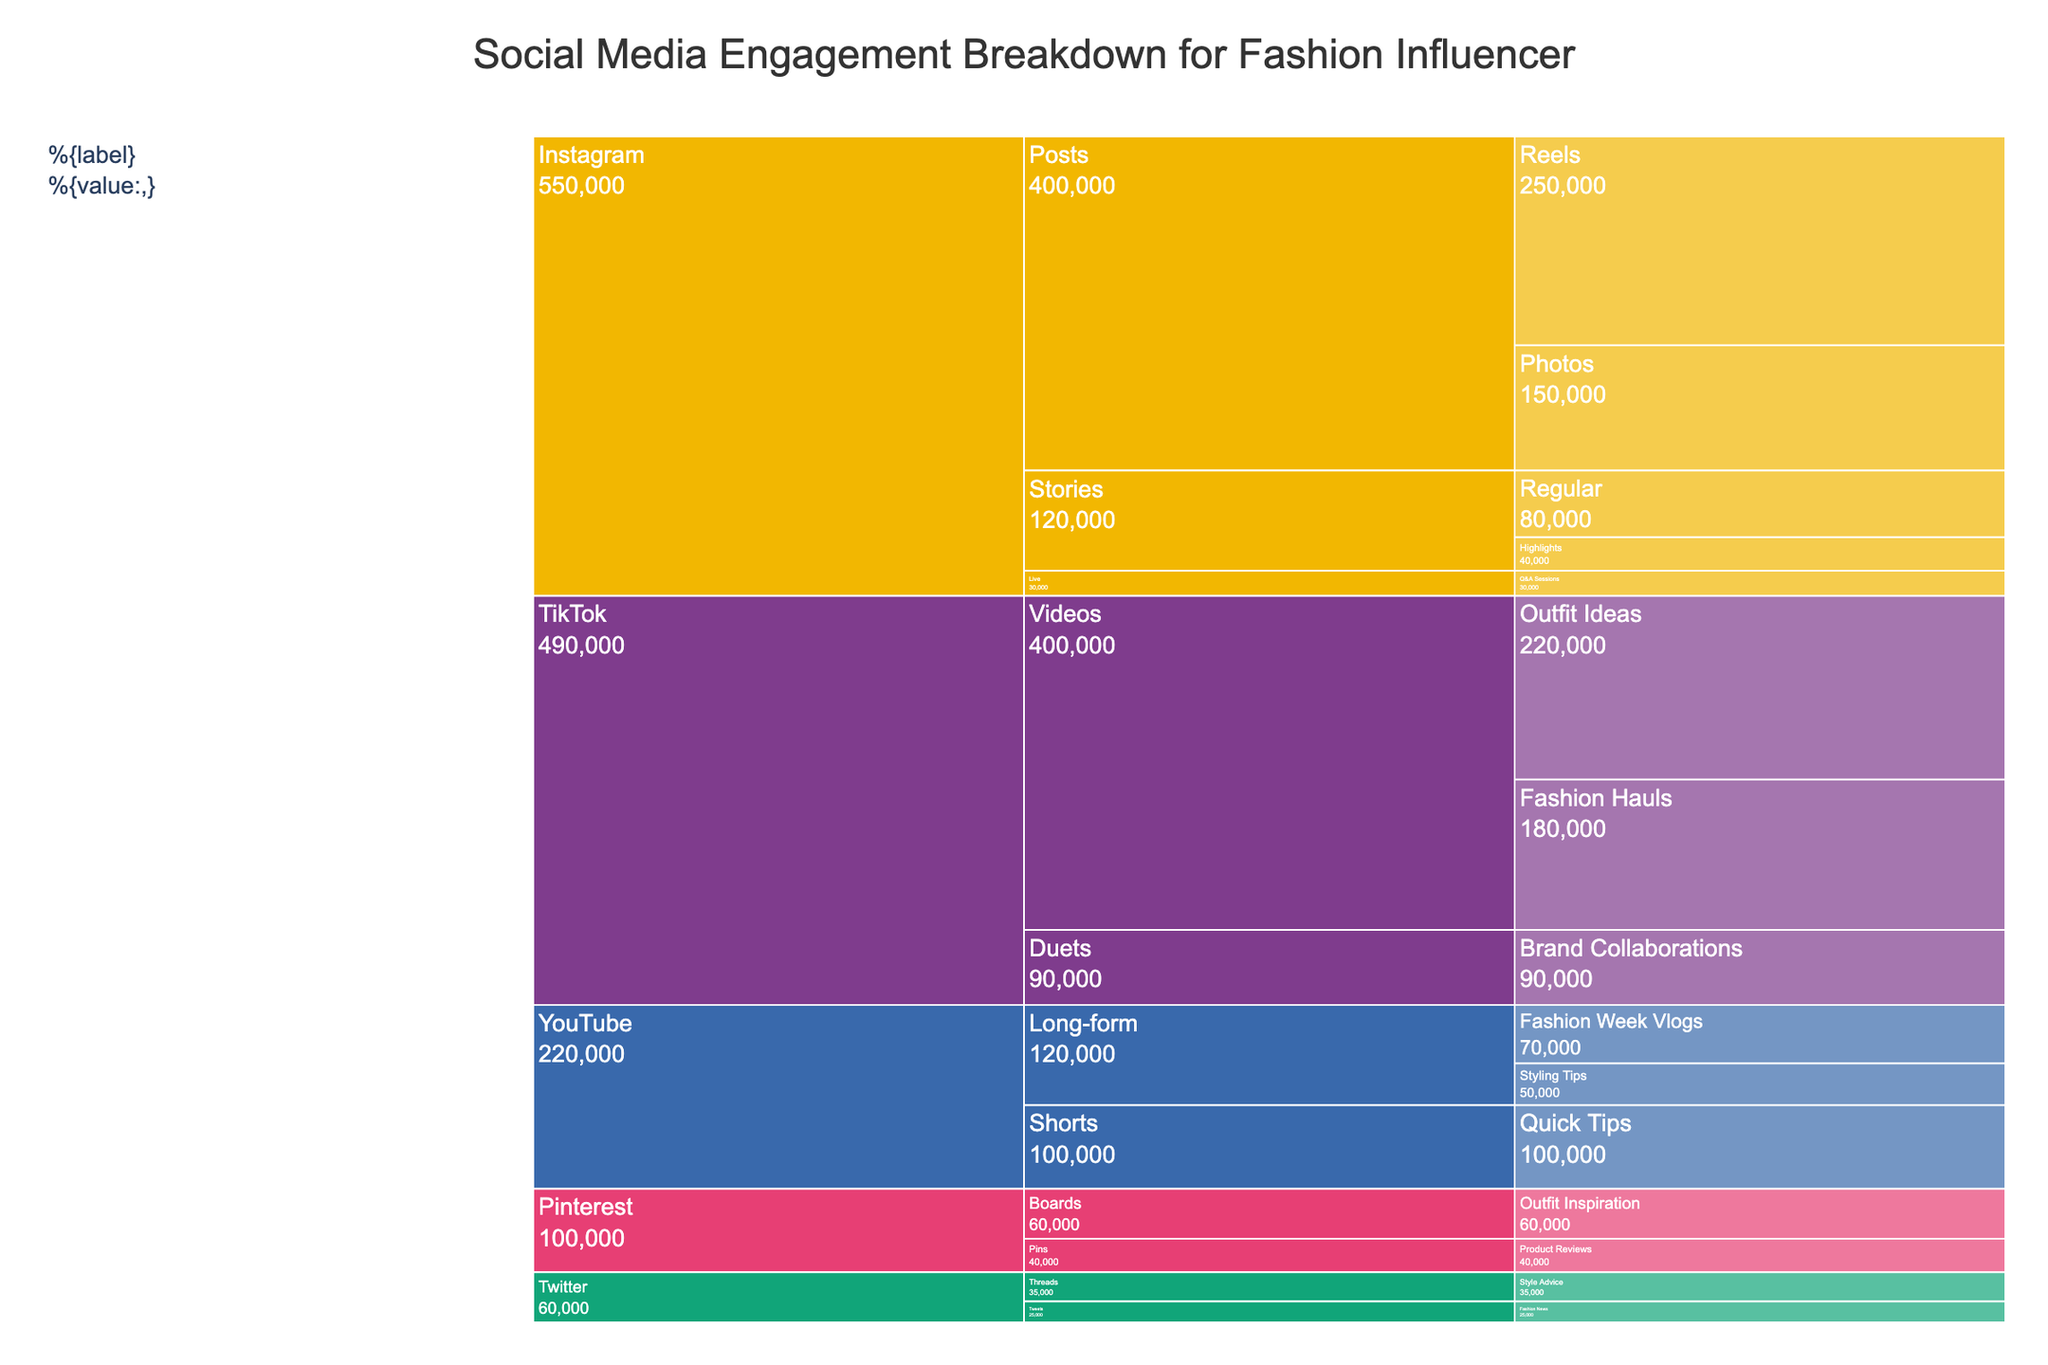Which platform has the highest engagement? Instagram has the highest engagement because it has the largest combined values of its subcategories when observed through the sizes of its rectangles in the Icicle Chart.
Answer: Instagram What is the total engagement from all TikTok videos? Sum the engagement of Fashion Hauls (180,000) and Outfit Ideas (220,000) under TikTok's Videos: 180,000 + 220,000 = 400,000.
Answer: 400,000 How does the engagement of Instagram Reels compare to YouTube's highest engagement subcategory? Instagram Reels has 250,000 engagements. YouTube’s highest engagement subcategory is Shorts with 100,000 engagements. Since 250,000 > 100,000, Instagram Reels has higher engagement.
Answer: Instagram Reels has higher engagement Which subcategory under Instagram Stories has more engagement? Under Instagram Stories, Regular has 80,000 engagements, and Highlights has 40,000 engagements. Since 80,000 > 40,000, Regular has more engagement.
Answer: Regular What is the sum of engagement from all Stories on Instagram? Sum the engagement of Regular Stories (80,000) and Highlights (40,000): 80,000 + 40,000 = 120,000.
Answer: 120,000 How does the engagement on Instagram Live compare to TikTok Duets for Brand Collaborations? Instagram Live (Q&A Sessions) has 30,000 engagements, while TikTok Duets for Brand Collaborations have 90,000. Since 30,000 < 90,000, TikTok Duets for Brand Collaborations have higher engagement.
Answer: TikTok Duets for Brand Collaborations have higher engagement What is the engagement difference between Pinterest Boards and Twitter Threads? Engagement for Pinterest Boards is 60,000, and for Twitter Threads is 35,000. The difference is 60,000 - 35,000 = 25,000.
Answer: 25,000 Which subcategory under YouTube has the lowest engagement value, and what is it? Under YouTube, Long-form Styling Tips have the lowest engagement with 50,000.
Answer: Long-form Styling Tips, 50,000 